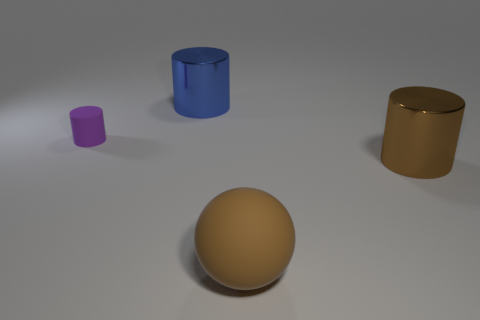What might be the purpose of creating this image? This image could serve various purposes: as a study in object rendering, showcasing different materials and colors, for product visualization, or even as a piece for an educational tool explaining concepts of geometry, light, and shadow. 